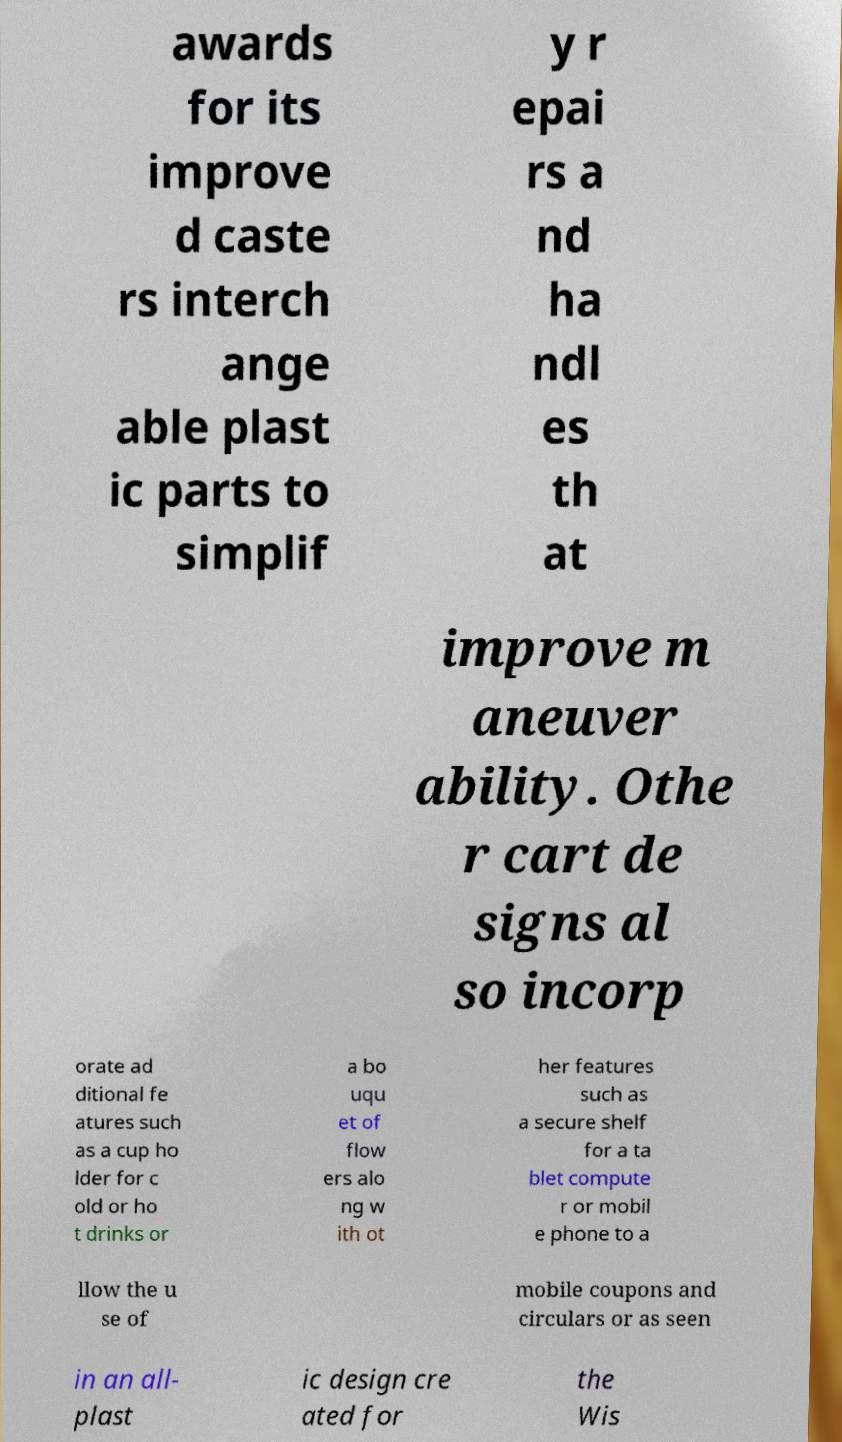Please read and relay the text visible in this image. What does it say? awards for its improve d caste rs interch ange able plast ic parts to simplif y r epai rs a nd ha ndl es th at improve m aneuver ability. Othe r cart de signs al so incorp orate ad ditional fe atures such as a cup ho lder for c old or ho t drinks or a bo uqu et of flow ers alo ng w ith ot her features such as a secure shelf for a ta blet compute r or mobil e phone to a llow the u se of mobile coupons and circulars or as seen in an all- plast ic design cre ated for the Wis 